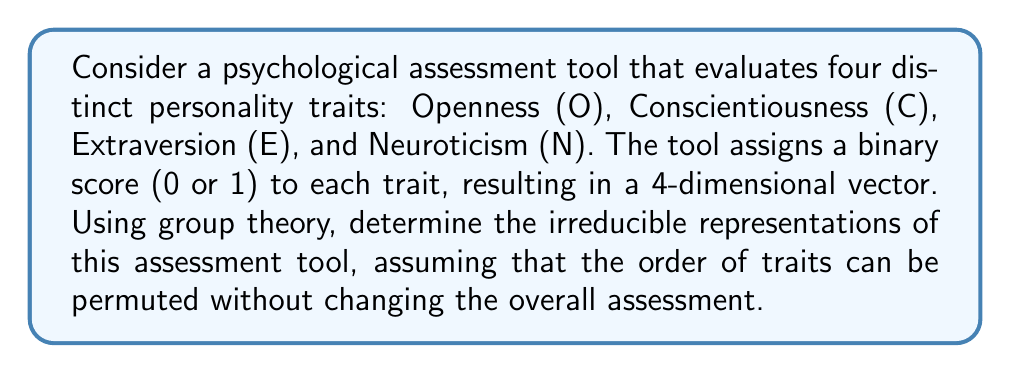Could you help me with this problem? To solve this problem, we'll follow these steps:

1) First, we need to identify the group that represents the symmetries of our assessment tool. Since the order of traits can be permuted, this corresponds to the symmetric group $S_4$.

2) The irreducible representations of $S_4$ are well-known. There are five of them, corresponding to the partitions of 4:
   - [4]: the trivial representation
   - [3,1]: the standard representation
   - [2,2]: the sign representation of $S_4/V_4$
   - [2,1,1]: the tensor product of the sign and standard representations
   - [1,1,1,1]: the sign representation

3) Now, we need to consider how these representations manifest in our psychological assessment tool:

   a) The [4] representation corresponds to the sum of all scores, which is invariant under all permutations.
   
   b) The [3,1] representation can be thought of as comparing one trait to the average of the others. For example:
      $$ 3O - (C + E + N) $$
   
   c) The [2,2] representation compares pairs of traits:
      $$ (O + C) - (E + N) $$
   
   d) The [2,1,1] representation compares one pair of traits to another:
      $$ (O - C) - (E - N) $$
   
   e) The [1,1,1,1] representation is the signed permutation, which doesn't have a meaningful interpretation in this context.

4) The dimensions of these representations are 1, 3, 2, 3, and 1 respectively, which sum to 10. This matches the total number of possible binary 4-vectors (2^4 = 16), confirming our analysis.

From a psychological perspective, these representations offer insights into how different combinations of traits might be interpreted:
- [4]: Overall level of traits
- [3,1]: Dominance of one trait over others
- [2,2]: Balance between pairs of traits
- [2,1,1]: Comparison of trait differences
Answer: The irreducible representations are: trivial [4], standard [3,1], sign of $S_4/V_4$ [2,2], tensor product of sign and standard [2,1,1], and sign [1,1,1,1]. 